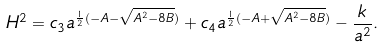Convert formula to latex. <formula><loc_0><loc_0><loc_500><loc_500>H ^ { 2 } = c _ { 3 } a ^ { \frac { 1 } { 2 } ( - A - \sqrt { A ^ { 2 } - 8 B } ) } + c _ { 4 } a ^ { \frac { 1 } { 2 } ( - A + \sqrt { A ^ { 2 } - 8 B } ) } - \frac { k } { a ^ { 2 } } .</formula> 